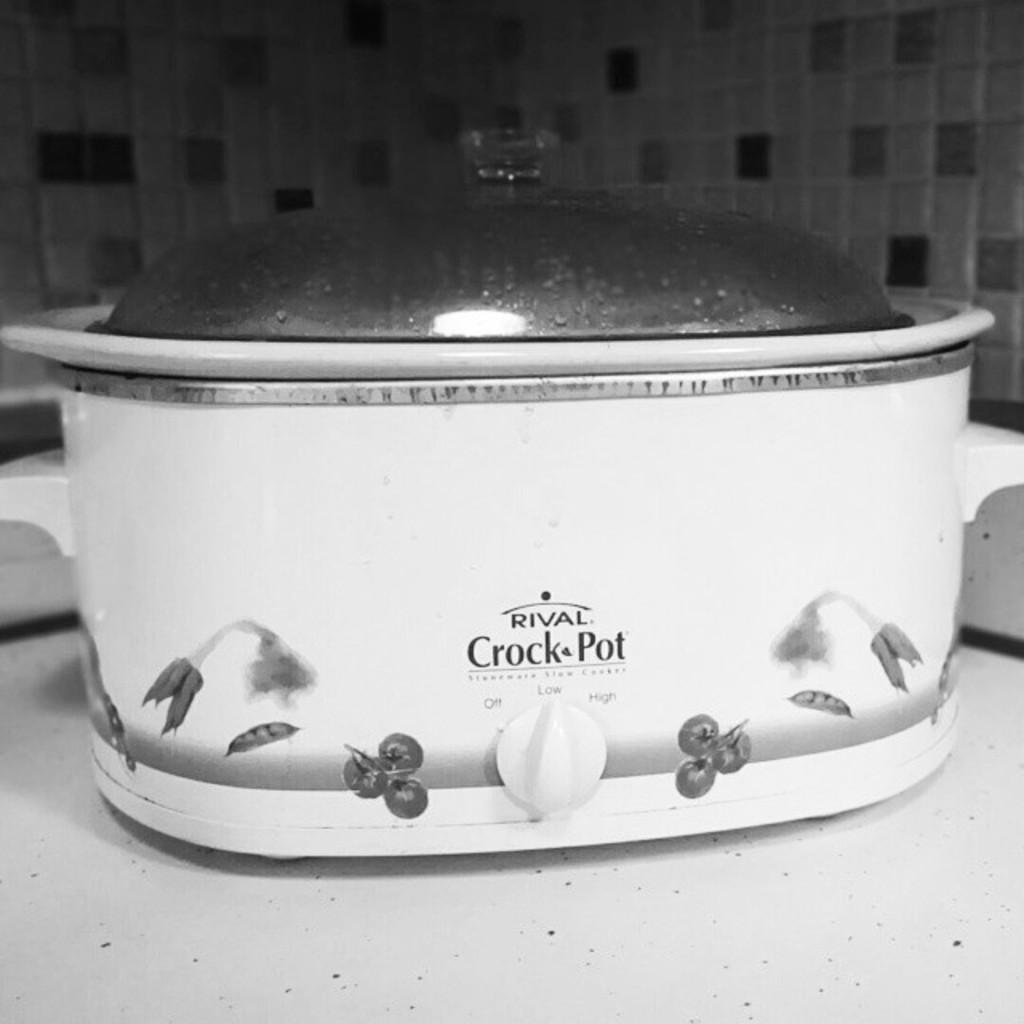<image>
Create a compact narrative representing the image presented. a pot that has the words crock pot on it 